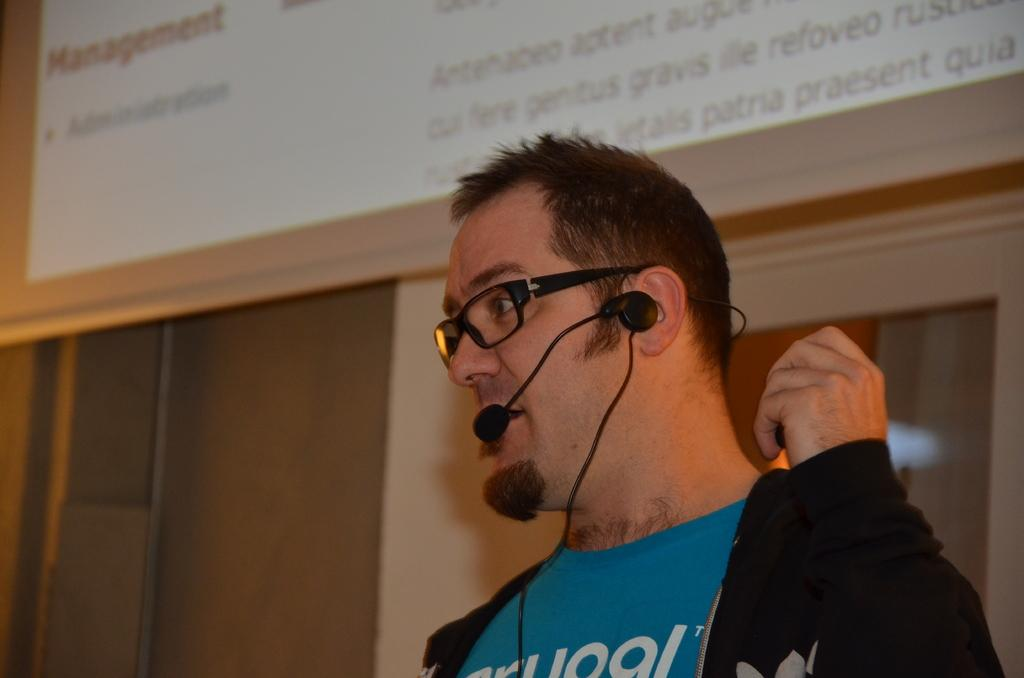What is the man in the image holding? The man is holding a microphone. What can be seen on the wall in the background of the image? There is a board on the wall in the background of the image. What else is visible in the background of the image? There are objects visible in the background of the image. What type of weather can be seen in the image? There is no indication of weather in the image, as it is an indoor setting with no visible windows or outdoor elements. 